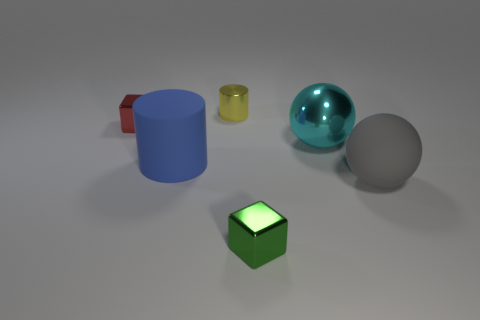There is another thing that is the same shape as the tiny red metallic object; what is its material?
Make the answer very short. Metal. The yellow thing that is the same size as the green object is what shape?
Offer a very short reply. Cylinder. Are there any big cyan shiny objects of the same shape as the large gray rubber thing?
Your answer should be very brief. Yes. The metal object to the right of the object in front of the gray sphere is what shape?
Give a very brief answer. Sphere. The large blue rubber thing is what shape?
Your response must be concise. Cylinder. What is the material of the object behind the block behind the cube that is to the right of the tiny cylinder?
Offer a very short reply. Metal. How many other objects are there of the same material as the yellow cylinder?
Give a very brief answer. 3. There is a big sphere that is on the right side of the metal sphere; how many metallic blocks are to the left of it?
Make the answer very short. 2. How many spheres are either big blue objects or large gray rubber things?
Your response must be concise. 1. What color is the big object that is both in front of the big cyan metallic thing and right of the green object?
Give a very brief answer. Gray. 